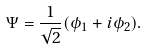<formula> <loc_0><loc_0><loc_500><loc_500>\Psi = \frac { 1 } { \sqrt { 2 } } ( \phi _ { 1 } + i \phi _ { 2 } ) .</formula> 